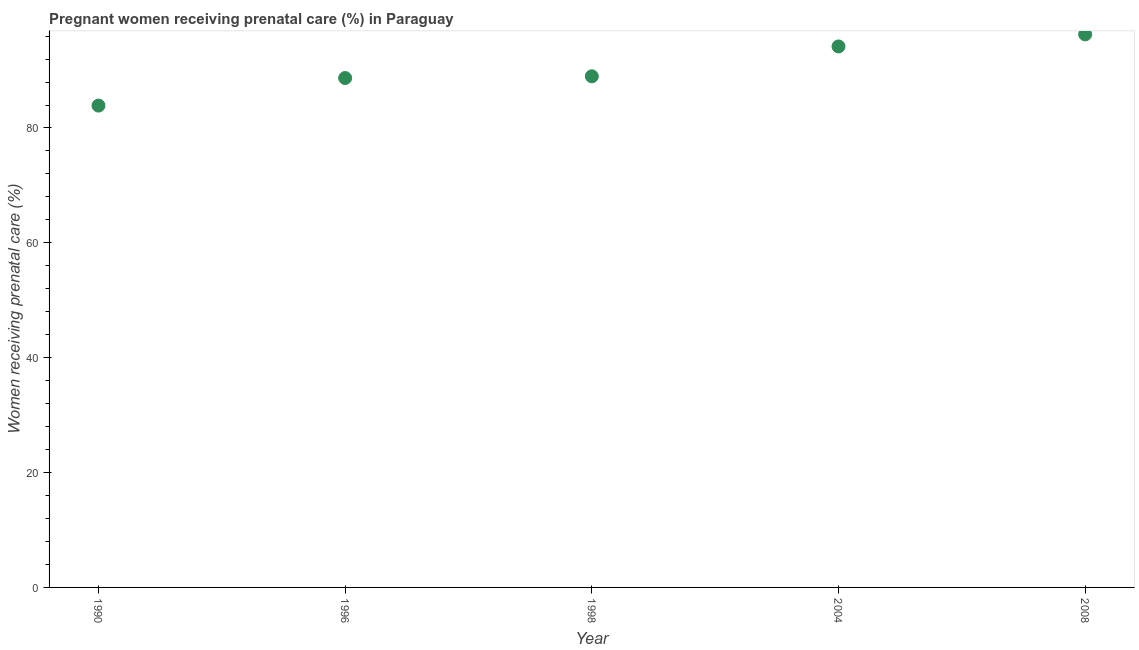What is the percentage of pregnant women receiving prenatal care in 2008?
Ensure brevity in your answer.  96.3. Across all years, what is the maximum percentage of pregnant women receiving prenatal care?
Offer a very short reply. 96.3. Across all years, what is the minimum percentage of pregnant women receiving prenatal care?
Offer a terse response. 83.9. In which year was the percentage of pregnant women receiving prenatal care maximum?
Your response must be concise. 2008. What is the sum of the percentage of pregnant women receiving prenatal care?
Offer a very short reply. 452.1. What is the difference between the percentage of pregnant women receiving prenatal care in 1996 and 1998?
Ensure brevity in your answer.  -0.3. What is the average percentage of pregnant women receiving prenatal care per year?
Give a very brief answer. 90.42. What is the median percentage of pregnant women receiving prenatal care?
Your answer should be very brief. 89. In how many years, is the percentage of pregnant women receiving prenatal care greater than 92 %?
Offer a very short reply. 2. What is the ratio of the percentage of pregnant women receiving prenatal care in 1996 to that in 2008?
Give a very brief answer. 0.92. What is the difference between the highest and the second highest percentage of pregnant women receiving prenatal care?
Give a very brief answer. 2.1. What is the difference between the highest and the lowest percentage of pregnant women receiving prenatal care?
Provide a succinct answer. 12.4. How many dotlines are there?
Your response must be concise. 1. How many years are there in the graph?
Provide a short and direct response. 5. What is the difference between two consecutive major ticks on the Y-axis?
Provide a short and direct response. 20. Are the values on the major ticks of Y-axis written in scientific E-notation?
Offer a terse response. No. Does the graph contain grids?
Offer a very short reply. No. What is the title of the graph?
Offer a terse response. Pregnant women receiving prenatal care (%) in Paraguay. What is the label or title of the X-axis?
Make the answer very short. Year. What is the label or title of the Y-axis?
Offer a very short reply. Women receiving prenatal care (%). What is the Women receiving prenatal care (%) in 1990?
Give a very brief answer. 83.9. What is the Women receiving prenatal care (%) in 1996?
Keep it short and to the point. 88.7. What is the Women receiving prenatal care (%) in 1998?
Keep it short and to the point. 89. What is the Women receiving prenatal care (%) in 2004?
Offer a terse response. 94.2. What is the Women receiving prenatal care (%) in 2008?
Your answer should be very brief. 96.3. What is the difference between the Women receiving prenatal care (%) in 1990 and 1998?
Offer a terse response. -5.1. What is the difference between the Women receiving prenatal care (%) in 1990 and 2008?
Provide a short and direct response. -12.4. What is the difference between the Women receiving prenatal care (%) in 1996 and 1998?
Make the answer very short. -0.3. What is the difference between the Women receiving prenatal care (%) in 1996 and 2008?
Provide a short and direct response. -7.6. What is the difference between the Women receiving prenatal care (%) in 1998 and 2008?
Offer a very short reply. -7.3. What is the difference between the Women receiving prenatal care (%) in 2004 and 2008?
Your response must be concise. -2.1. What is the ratio of the Women receiving prenatal care (%) in 1990 to that in 1996?
Your answer should be very brief. 0.95. What is the ratio of the Women receiving prenatal care (%) in 1990 to that in 1998?
Provide a succinct answer. 0.94. What is the ratio of the Women receiving prenatal care (%) in 1990 to that in 2004?
Provide a short and direct response. 0.89. What is the ratio of the Women receiving prenatal care (%) in 1990 to that in 2008?
Provide a succinct answer. 0.87. What is the ratio of the Women receiving prenatal care (%) in 1996 to that in 1998?
Give a very brief answer. 1. What is the ratio of the Women receiving prenatal care (%) in 1996 to that in 2004?
Provide a succinct answer. 0.94. What is the ratio of the Women receiving prenatal care (%) in 1996 to that in 2008?
Provide a succinct answer. 0.92. What is the ratio of the Women receiving prenatal care (%) in 1998 to that in 2004?
Give a very brief answer. 0.94. What is the ratio of the Women receiving prenatal care (%) in 1998 to that in 2008?
Make the answer very short. 0.92. 